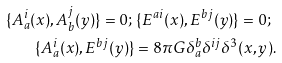<formula> <loc_0><loc_0><loc_500><loc_500>\{ A _ { a } ^ { i } ( x ) , A _ { b } ^ { j } ( y ) \} = 0 ; \, & \, \{ E ^ { a i } ( x ) , E ^ { b j } ( y ) \} = 0 ; \\ \{ A _ { a } ^ { i } ( x ) , E ^ { b j } ( y ) \} & = 8 \pi G \delta _ { a } ^ { b } \delta ^ { i j } \delta ^ { 3 } ( x , y ) .</formula> 